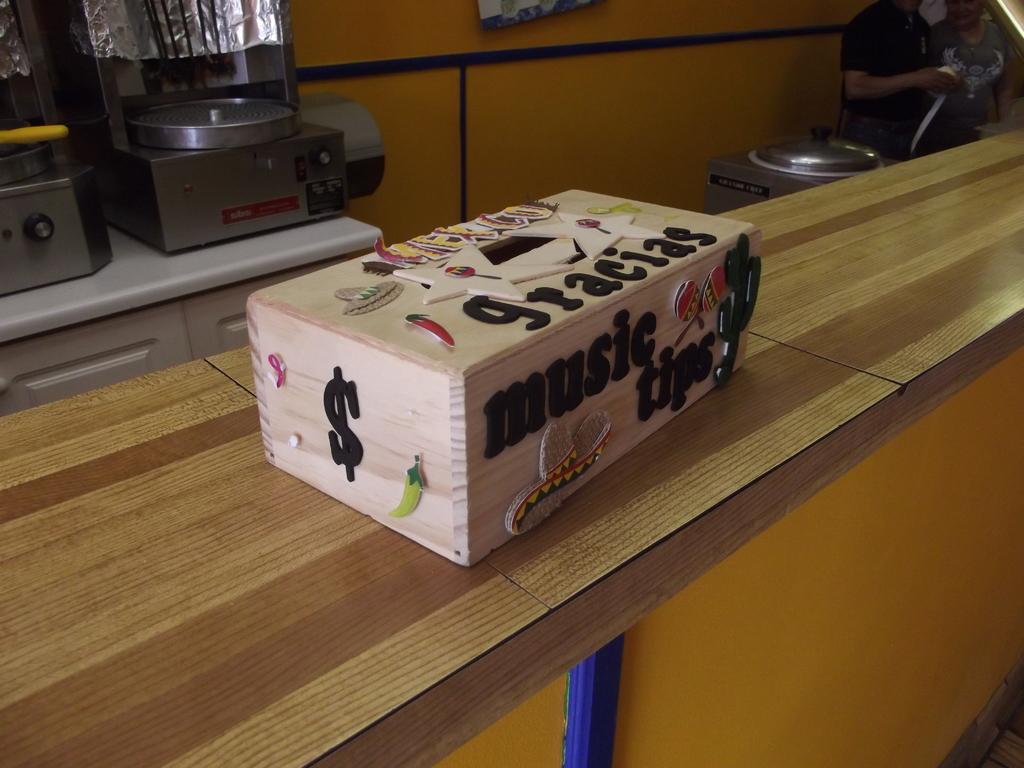I wonder what is inside the box?
Your response must be concise. Music tips. What are the tips for?
Offer a terse response. Music. 